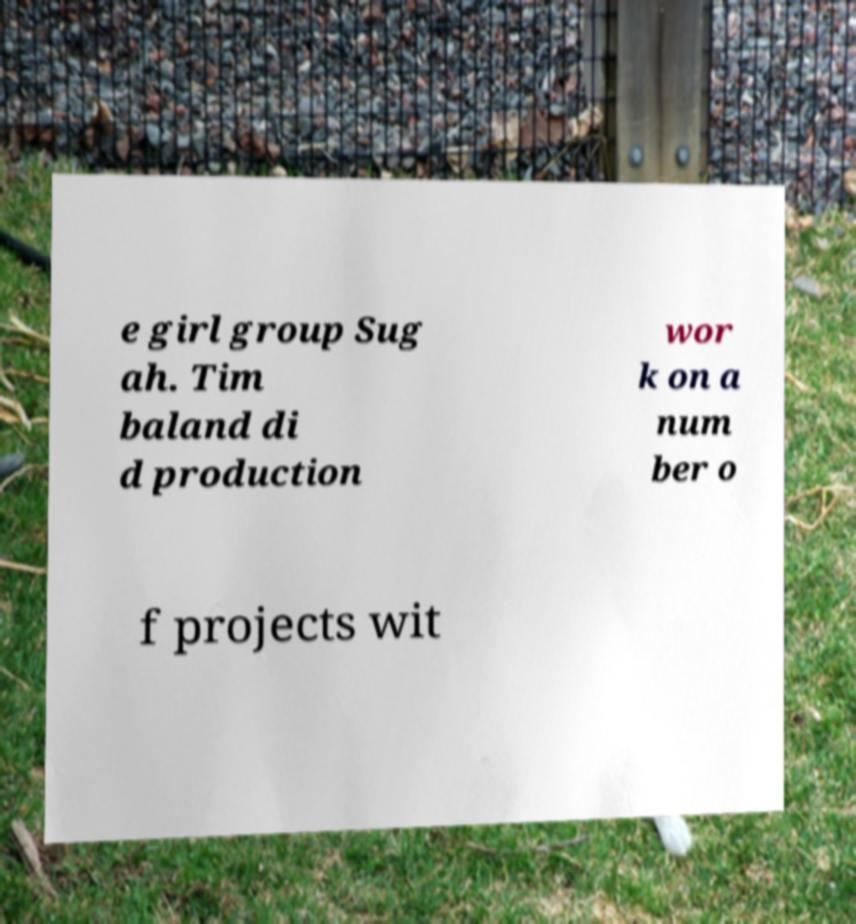There's text embedded in this image that I need extracted. Can you transcribe it verbatim? e girl group Sug ah. Tim baland di d production wor k on a num ber o f projects wit 